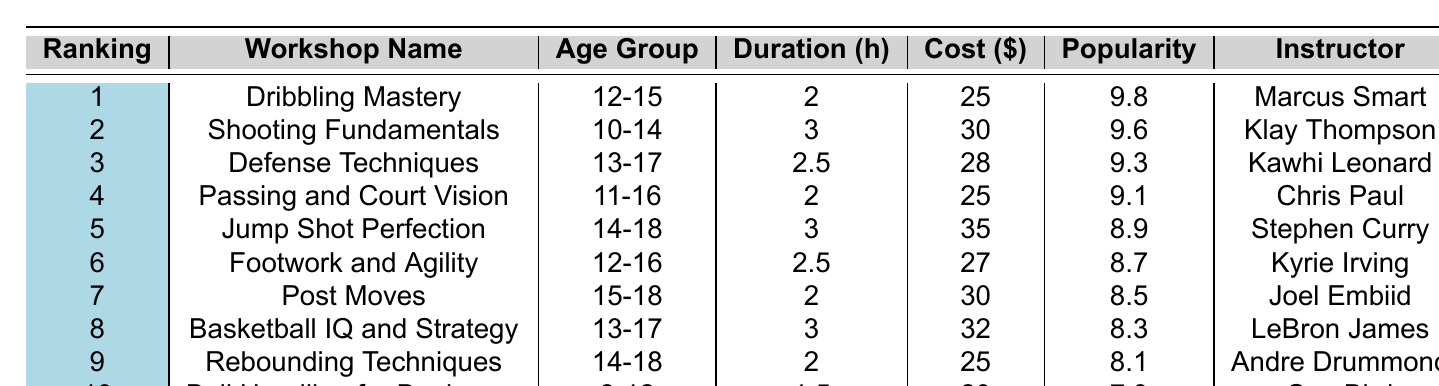What is the most popular basketball skills workshop according to the table? The table lists "Dribbling Mastery" as the workshop with the highest ranking (1) and the highest popularity score (9.8).
Answer: Dribbling Mastery Which age group is associated with the workshop "Jump Shot Perfection"? The age group listed for "Jump Shot Perfection" is 14-18.
Answer: 14-18 What is the cost of the "Footwork and Agility" workshop? The table indicates that the cost for "Footwork and Agility" is $27.
Answer: $27 How many hours does the "Passing and Court Vision" workshop last? The duration of the "Passing and Court Vision" workshop is 2 hours, as stated in the table.
Answer: 2 hours True or False: "Shooting Fundamentals" is the most expensive workshop. "Shooting Fundamentals" costs $30, but "Jump Shot Perfection" costs $35, making it not the most expensive.
Answer: False What is the average popularity score of the top three workshops? The popularity scores for the top three workshops are 9.8 (Dribbling Mastery), 9.6 (Shooting Fundamentals), and 9.3 (Defense Techniques). Their sum is 9.8 + 9.6 + 9.3 = 28.7. Dividing by 3 gives an average of 28.7 / 3 = 9.57.
Answer: 9.57 Which workshops have a popularity score above 9? The workshops with scores above 9 are: "Dribbling Mastery" (9.8), "Shooting Fundamentals" (9.6), "Defense Techniques" (9.3), "Passing and Court Vision" (9.1), and "Jump Shot Perfection" (8.9).
Answer: 5 workshops What is the difference in cost between the cheapest and the most expensive workshop? The cheapest workshop is "Ball Handling for Beginners" at $20 and the most expensive is "Jump Shot Perfection" at $35. The difference is $35 - $20 = $15.
Answer: $15 Which instructor teaches the highest-ranked workshop, and what is their rank? The highest-ranked workshop is "Dribbling Mastery," taught by Marcus Smart. The rank is 1.
Answer: Marcus Smart, Rank 1 Which two workshops have the same duration of 2 hours, and what are their popularity scores? "Dribbling Mastery" and "Post Moves" both have a duration of 2 hours. Their popularity scores are 9.8 and 8.5, respectively.
Answer: Dribbling Mastery (9.8), Post Moves (8.5) 